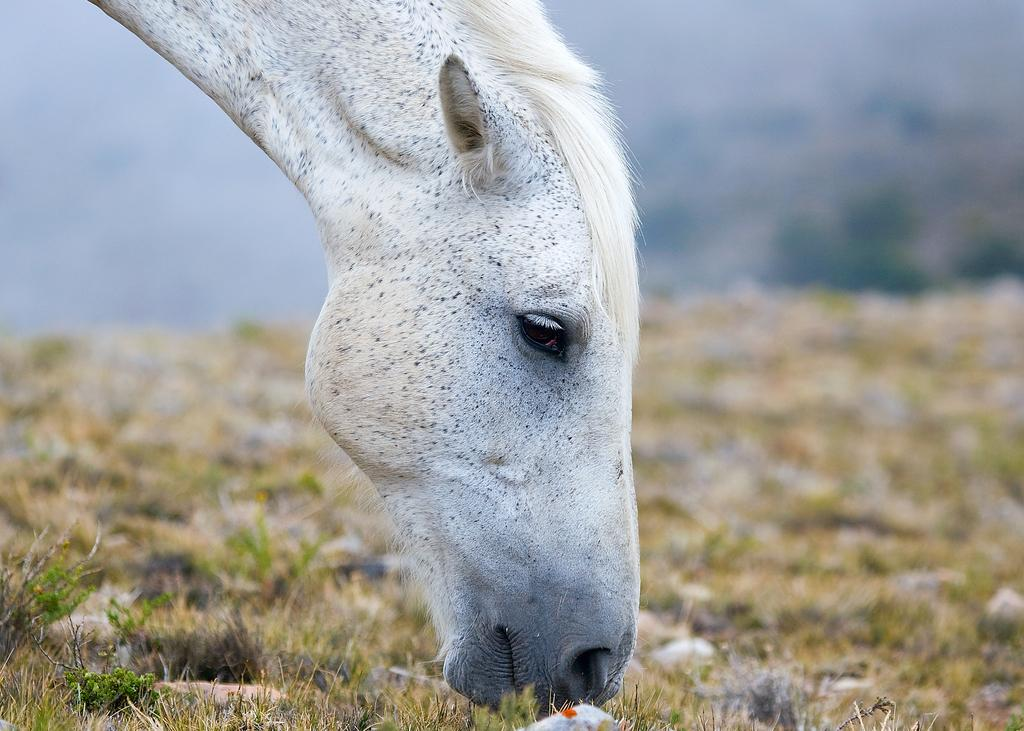What animal is present in the image? There is a white horse in the image. What type of terrain is visible at the bottom of the image? Grass and stones are visible at the bottom of the image. How would you describe the background of the image? The background of the image has a blurred view. How many apples can be seen in the hand of the horse in the image? There are no apples or hands visible in the image; it features a white horse on a grassy and stony terrain with a blurred background. 